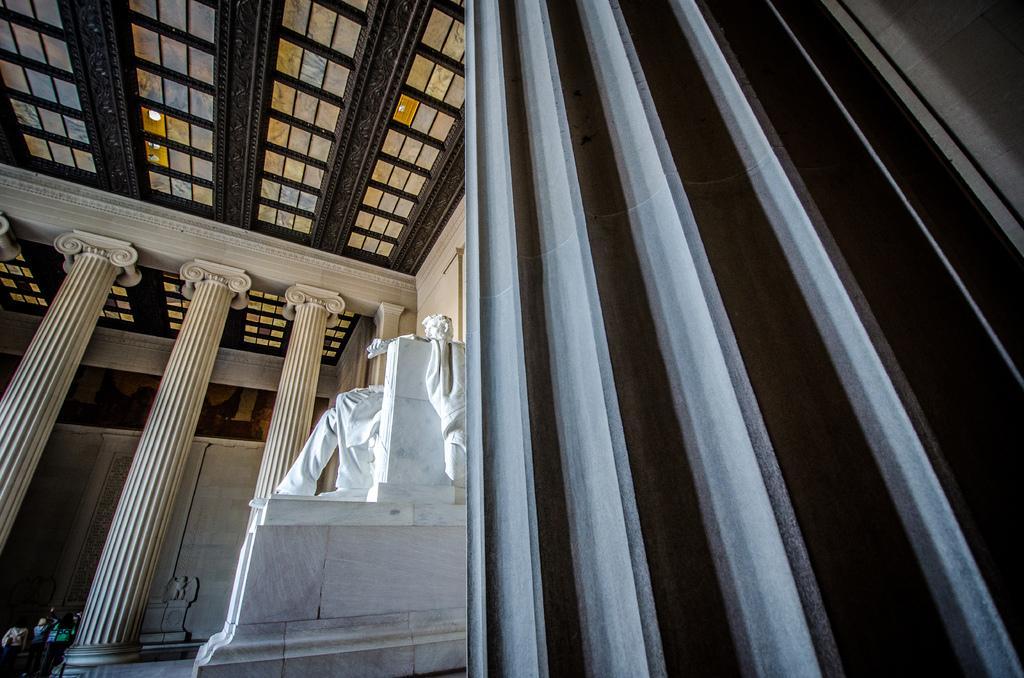How would you summarize this image in a sentence or two? In this image I see the inside view of a building and I see the sculpture over here which is of white in color and I see the pillars over here which are of cream in color and I see the wall. 